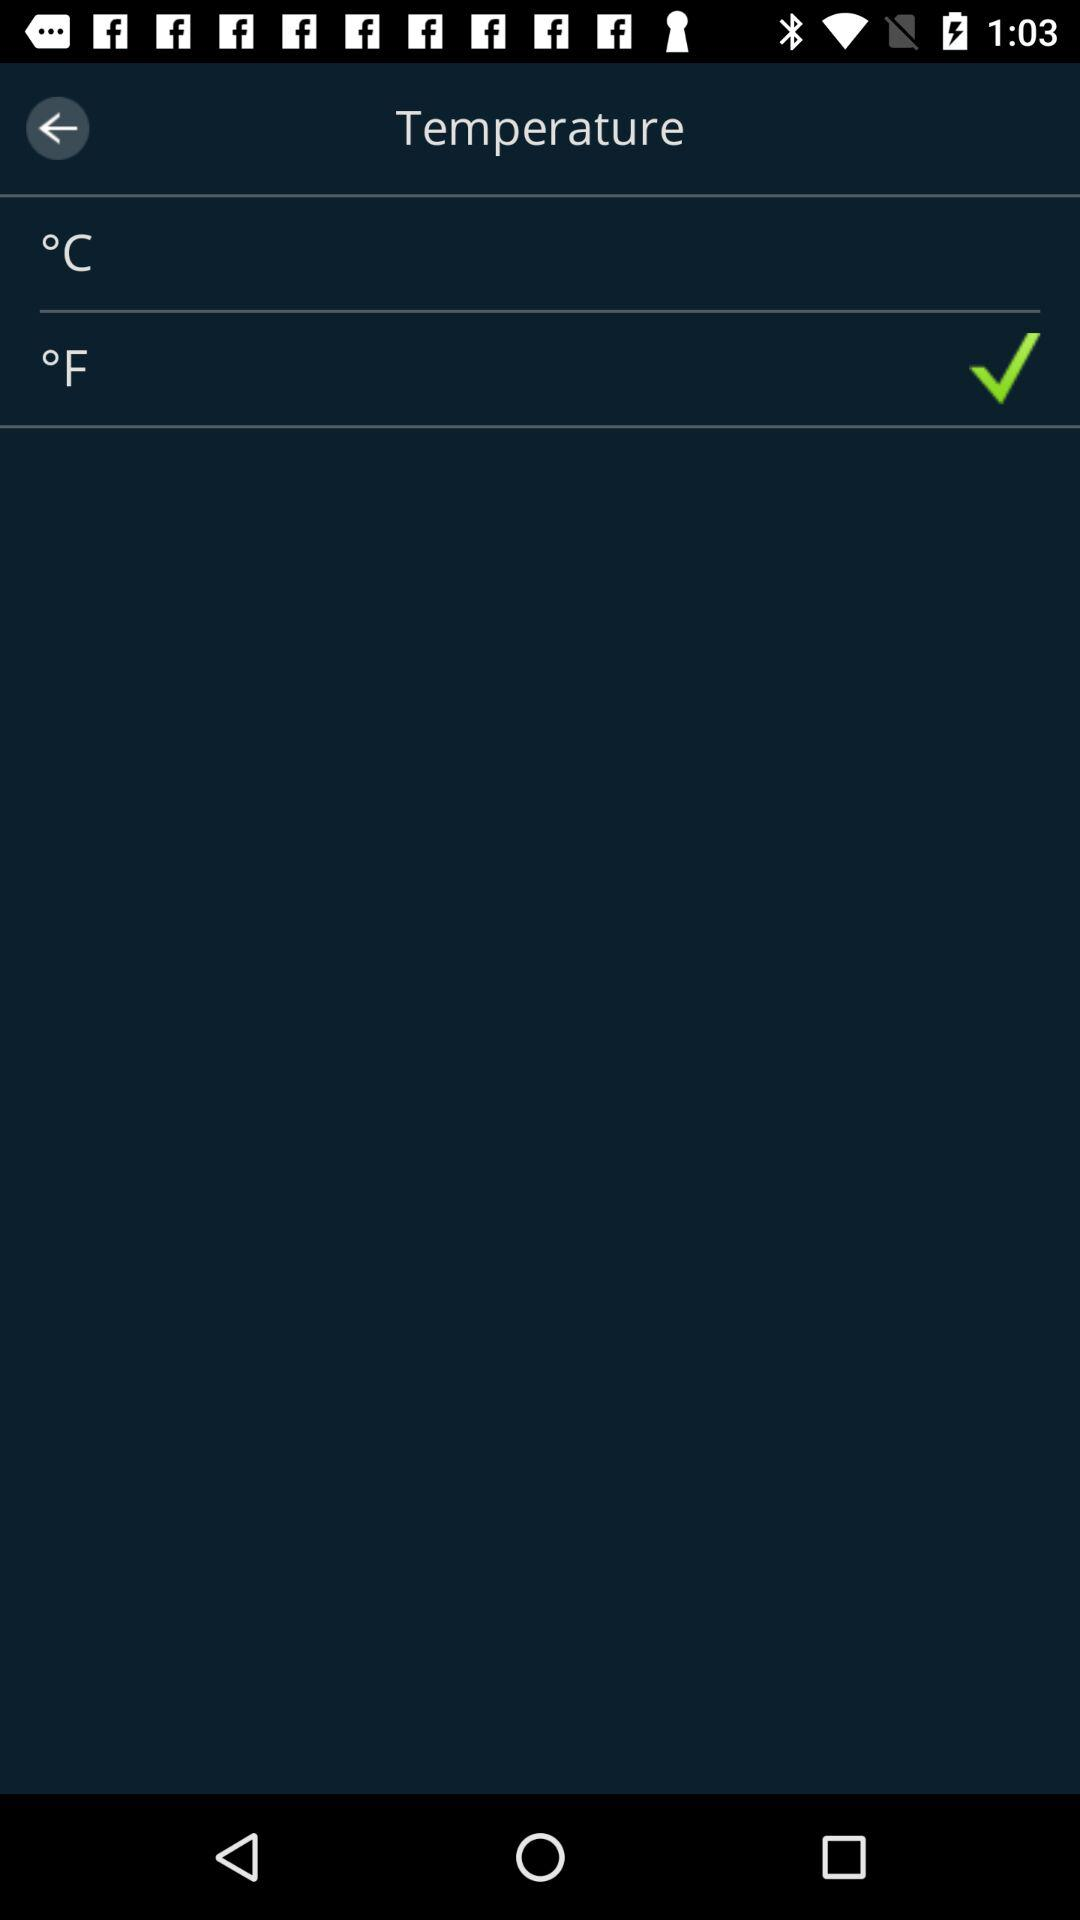Which temperature is higher, °C or °F?
Answer the question using a single word or phrase. °F 